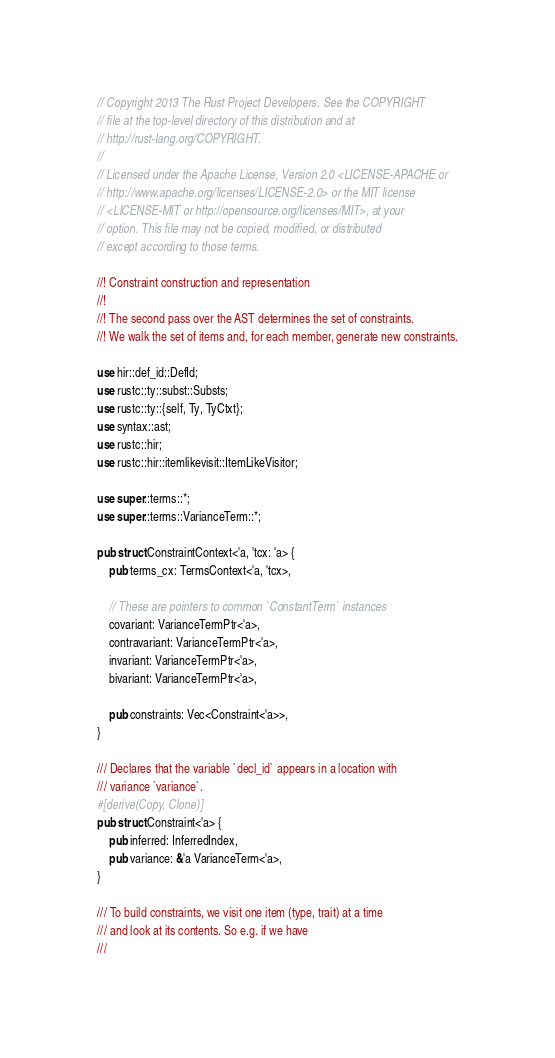<code> <loc_0><loc_0><loc_500><loc_500><_Rust_>// Copyright 2013 The Rust Project Developers. See the COPYRIGHT
// file at the top-level directory of this distribution and at
// http://rust-lang.org/COPYRIGHT.
//
// Licensed under the Apache License, Version 2.0 <LICENSE-APACHE or
// http://www.apache.org/licenses/LICENSE-2.0> or the MIT license
// <LICENSE-MIT or http://opensource.org/licenses/MIT>, at your
// option. This file may not be copied, modified, or distributed
// except according to those terms.

//! Constraint construction and representation
//!
//! The second pass over the AST determines the set of constraints.
//! We walk the set of items and, for each member, generate new constraints.

use hir::def_id::DefId;
use rustc::ty::subst::Substs;
use rustc::ty::{self, Ty, TyCtxt};
use syntax::ast;
use rustc::hir;
use rustc::hir::itemlikevisit::ItemLikeVisitor;

use super::terms::*;
use super::terms::VarianceTerm::*;

pub struct ConstraintContext<'a, 'tcx: 'a> {
    pub terms_cx: TermsContext<'a, 'tcx>,

    // These are pointers to common `ConstantTerm` instances
    covariant: VarianceTermPtr<'a>,
    contravariant: VarianceTermPtr<'a>,
    invariant: VarianceTermPtr<'a>,
    bivariant: VarianceTermPtr<'a>,

    pub constraints: Vec<Constraint<'a>>,
}

/// Declares that the variable `decl_id` appears in a location with
/// variance `variance`.
#[derive(Copy, Clone)]
pub struct Constraint<'a> {
    pub inferred: InferredIndex,
    pub variance: &'a VarianceTerm<'a>,
}

/// To build constraints, we visit one item (type, trait) at a time
/// and look at its contents. So e.g. if we have
///</code> 